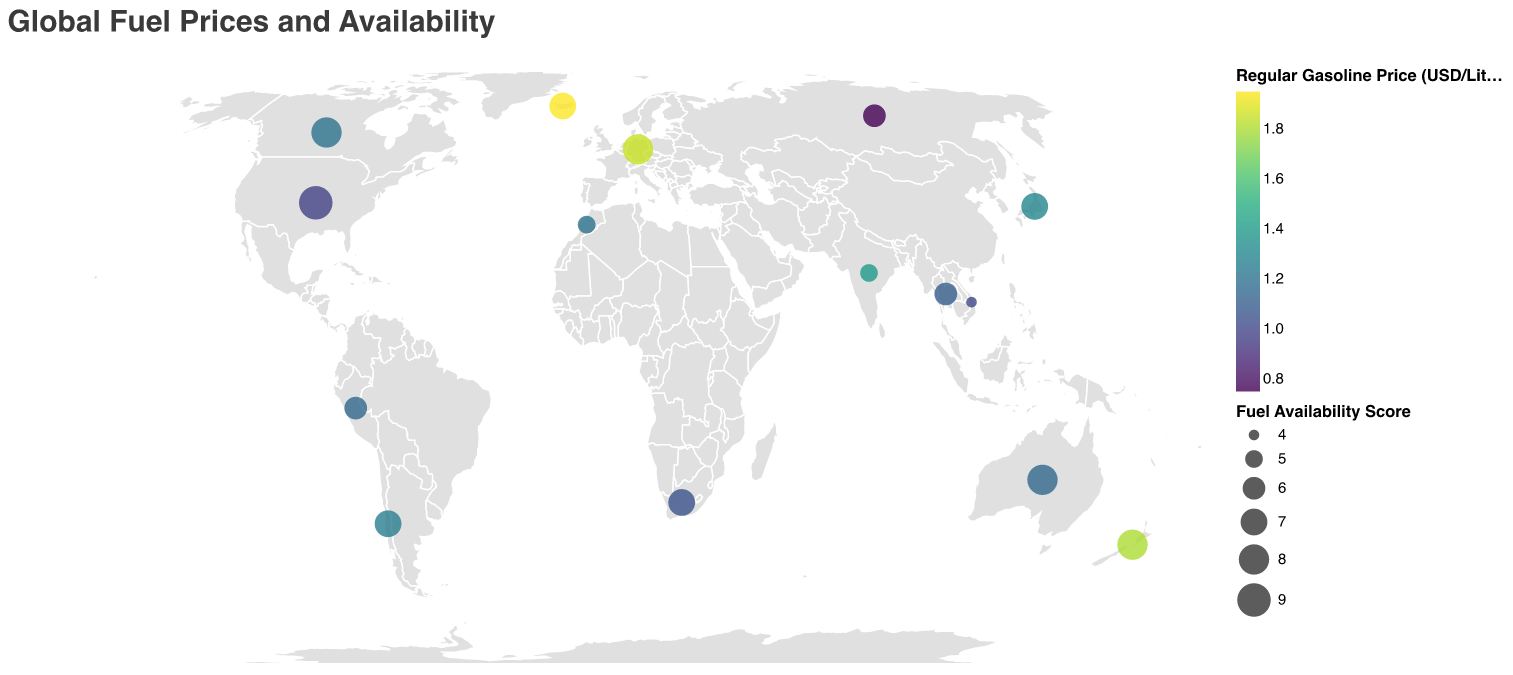What's the title of the plot? The plot's title is displayed at the top using the font "Helvetica." The color is gray (#3a3a3a) and the title text reads "Global Fuel Prices and Availability."
Answer: Global Fuel Prices and Availability What color scheme is used for representing regular gasoline prices? The color scheme for representing regular gasoline prices is viridis, a sequential colormap often used for its perceptual uniformity.
Answer: viridis Which country has the highest fuel availability score? The country with the highest fuel availability score can be identified by the size of the circle representing it on the plot. The United States has the largest circle, indicating a fuel availability score of 9.
Answer: United States Compare the regular gasoline prices between Germany and Russia. Which country has higher prices? By observing the colors of the circles, Germany has a darker shade, indicating a higher regular gasoline price compared to Russia. Specifically, Germany has $1.85 per liter, and Russia has $0.75 per liter.
Answer: Germany What is the size range of the circles representing the Fuel Availability Score? The legend indicates the size of the circles changes according to the Fuel Availability Scores. The legend shows the domain is from 4 to 9, the range in size is from 50 to 500.
Answer: 50 to 500 Which two countries have the highest premium gasoline prices, and what are their prices? By observing the tooltip data, Iceland and Germany have the highest premium gasoline prices, with prices at $2.20 and $2.10 per liter, respectively.
Answer: Iceland, Germany Find the median price of regular gasoline from the listed countries. To find the median, list the regular gasoline prices in ascending order: 0.75, 0.98, 1.00, 1.05, 1.10, 1.15, 1.15, 1.20, 1.20, 1.25, 1.30, 1.30, 1.40, 1.80, 1.85, 1.95. The middle values are 1.20 and 1.25, so the median is: (1.20 + 1.25) / 2 = 1.225
Answer: 1.225 Which region generally has lower fuel prices, North America or Europe? By comparing the colors of circles in North America (United States, Canada) with those in Europe (Germany, Iceland), the U.S. ($0.98/L) and Canada ($1.20/L) generally exhibit lighter colors indicating lower fuel prices compared to the darker color of Germany ($1.85/L) and Iceland ($1.95/L).
Answer: North America What are the fuel availability scores for South Africa and Vietnam? Which country has a higher score? By checking the tooltip data, South Africa has a Fuel Availability Score of 7, and Vietnam has a score of 4. Therefore, South Africa has a higher score.
Answer: South Africa What is the relationship between regular gasoline price and fuel availability score for countries with higher prices? Countries with higher regular gasoline prices, like Germany ($1.85/L), Iceland ($1.95/L), and New Zealand ($1.80/L), tend to have higher Fuel Availability Scores, specifically 8, 7, and 8 respectively.
Answer: Direct relationship 